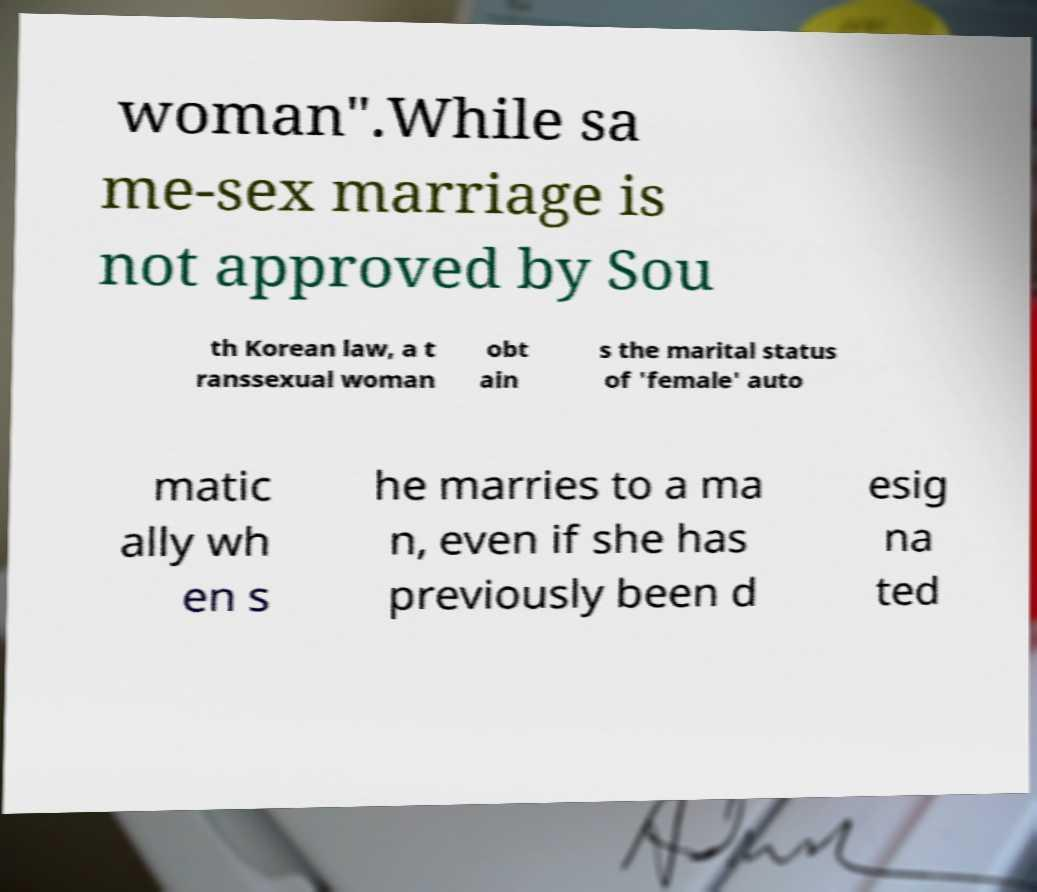What messages or text are displayed in this image? I need them in a readable, typed format. woman".While sa me-sex marriage is not approved by Sou th Korean law, a t ranssexual woman obt ain s the marital status of 'female' auto matic ally wh en s he marries to a ma n, even if she has previously been d esig na ted 